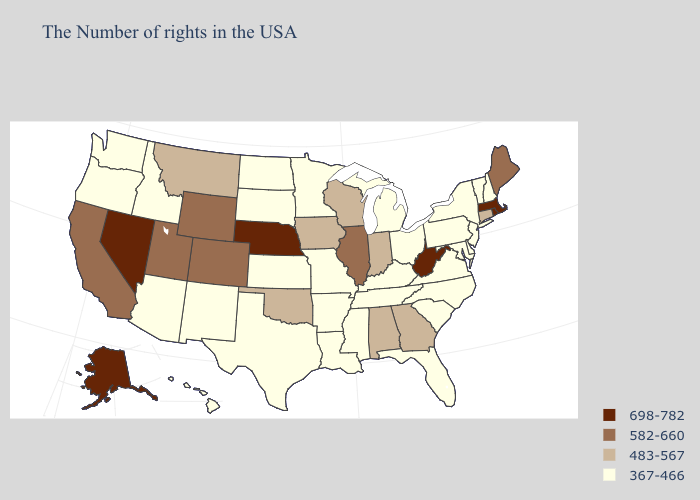Which states have the highest value in the USA?
Concise answer only. Massachusetts, Rhode Island, West Virginia, Nebraska, Nevada, Alaska. Does Tennessee have a lower value than Montana?
Write a very short answer. Yes. What is the highest value in states that border Wisconsin?
Answer briefly. 582-660. What is the lowest value in states that border Idaho?
Short answer required. 367-466. What is the value of Iowa?
Concise answer only. 483-567. Does Massachusetts have the highest value in the USA?
Keep it brief. Yes. Does the first symbol in the legend represent the smallest category?
Be succinct. No. Among the states that border New Mexico , which have the highest value?
Quick response, please. Colorado, Utah. Name the states that have a value in the range 582-660?
Be succinct. Maine, Illinois, Wyoming, Colorado, Utah, California. What is the value of North Dakota?
Answer briefly. 367-466. Does the first symbol in the legend represent the smallest category?
Be succinct. No. Does Colorado have a lower value than Oregon?
Keep it brief. No. Which states hav the highest value in the MidWest?
Answer briefly. Nebraska. Name the states that have a value in the range 483-567?
Concise answer only. Connecticut, Georgia, Indiana, Alabama, Wisconsin, Iowa, Oklahoma, Montana. Name the states that have a value in the range 367-466?
Write a very short answer. New Hampshire, Vermont, New York, New Jersey, Delaware, Maryland, Pennsylvania, Virginia, North Carolina, South Carolina, Ohio, Florida, Michigan, Kentucky, Tennessee, Mississippi, Louisiana, Missouri, Arkansas, Minnesota, Kansas, Texas, South Dakota, North Dakota, New Mexico, Arizona, Idaho, Washington, Oregon, Hawaii. 